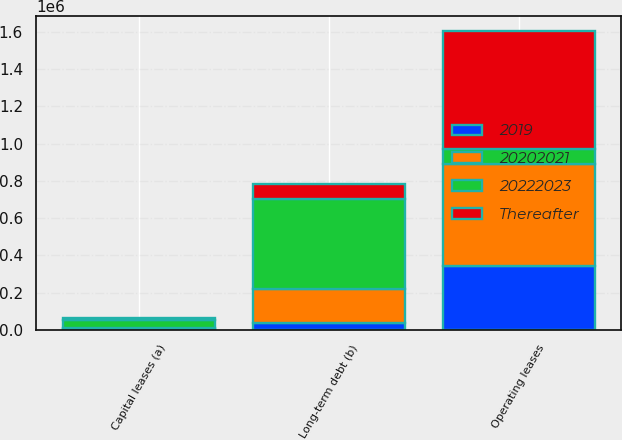Convert chart. <chart><loc_0><loc_0><loc_500><loc_500><stacked_bar_chart><ecel><fcel>Operating leases<fcel>Capital leases (a)<fcel>Long-term debt (b)<nl><fcel>20222023<fcel>80181<fcel>43064<fcel>483442<nl><fcel>2019<fcel>344836<fcel>5215<fcel>37280<nl><fcel>Thereafter<fcel>635161<fcel>10528<fcel>80181<nl><fcel>20202021<fcel>544845<fcel>7152<fcel>184747<nl></chart> 